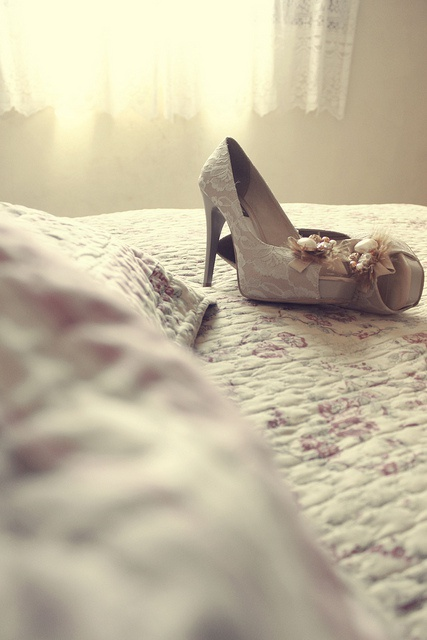Describe the objects in this image and their specific colors. I can see a bed in lightyellow, darkgray, beige, and tan tones in this image. 